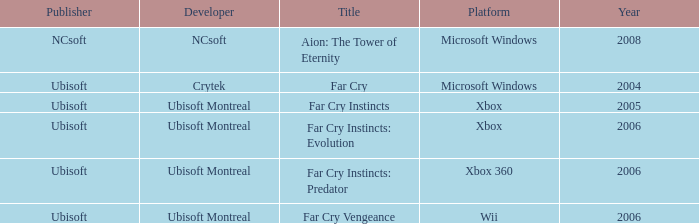What is the average year that has far cry vengeance as the title? 2006.0. 